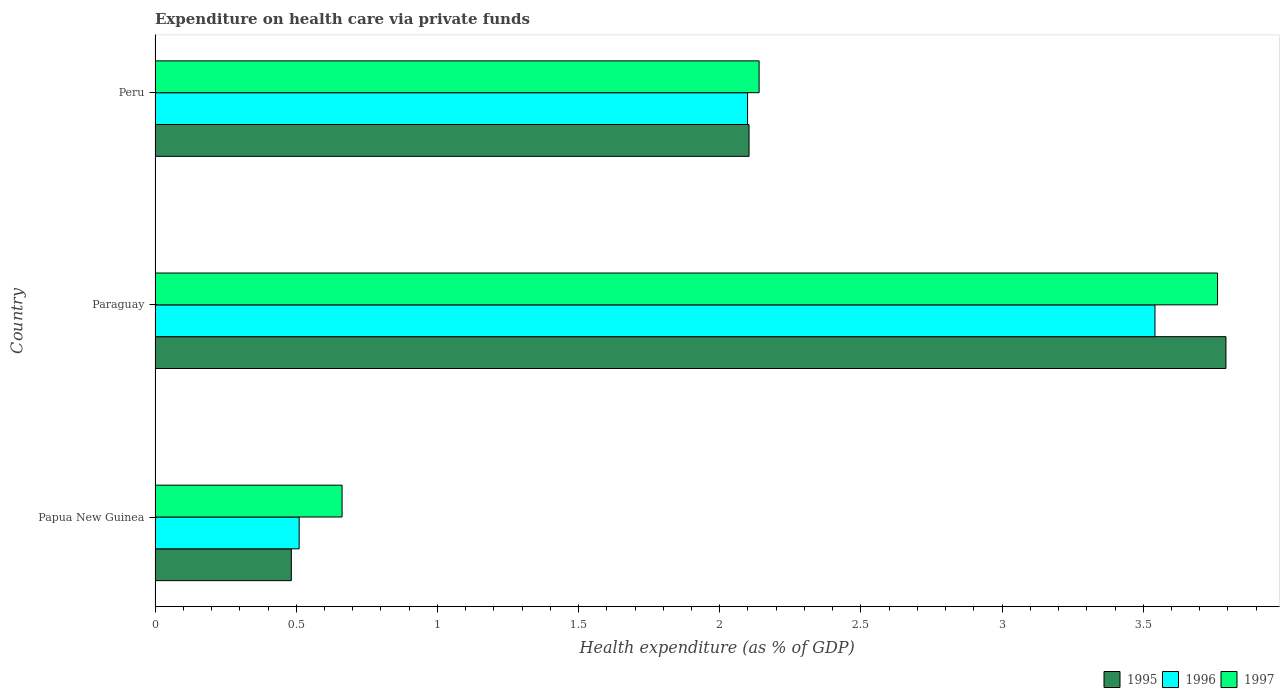How many different coloured bars are there?
Provide a short and direct response. 3. Are the number of bars per tick equal to the number of legend labels?
Your answer should be very brief. Yes. Are the number of bars on each tick of the Y-axis equal?
Give a very brief answer. Yes. What is the label of the 3rd group of bars from the top?
Ensure brevity in your answer.  Papua New Guinea. In how many cases, is the number of bars for a given country not equal to the number of legend labels?
Offer a very short reply. 0. What is the expenditure made on health care in 1997 in Peru?
Keep it short and to the point. 2.14. Across all countries, what is the maximum expenditure made on health care in 1997?
Provide a succinct answer. 3.76. Across all countries, what is the minimum expenditure made on health care in 1997?
Your answer should be very brief. 0.66. In which country was the expenditure made on health care in 1997 maximum?
Provide a succinct answer. Paraguay. In which country was the expenditure made on health care in 1995 minimum?
Ensure brevity in your answer.  Papua New Guinea. What is the total expenditure made on health care in 1996 in the graph?
Provide a short and direct response. 6.15. What is the difference between the expenditure made on health care in 1996 in Papua New Guinea and that in Peru?
Keep it short and to the point. -1.59. What is the difference between the expenditure made on health care in 1997 in Papua New Guinea and the expenditure made on health care in 1996 in Paraguay?
Provide a short and direct response. -2.88. What is the average expenditure made on health care in 1996 per country?
Keep it short and to the point. 2.05. What is the difference between the expenditure made on health care in 1997 and expenditure made on health care in 1996 in Peru?
Your response must be concise. 0.04. What is the ratio of the expenditure made on health care in 1997 in Papua New Guinea to that in Paraguay?
Make the answer very short. 0.18. What is the difference between the highest and the second highest expenditure made on health care in 1995?
Ensure brevity in your answer.  1.69. What is the difference between the highest and the lowest expenditure made on health care in 1995?
Give a very brief answer. 3.31. What does the 2nd bar from the bottom in Papua New Guinea represents?
Ensure brevity in your answer.  1996. Is it the case that in every country, the sum of the expenditure made on health care in 1996 and expenditure made on health care in 1997 is greater than the expenditure made on health care in 1995?
Make the answer very short. Yes. How many bars are there?
Your answer should be compact. 9. What is the difference between two consecutive major ticks on the X-axis?
Offer a very short reply. 0.5. Does the graph contain grids?
Your answer should be compact. No. How many legend labels are there?
Your response must be concise. 3. What is the title of the graph?
Ensure brevity in your answer.  Expenditure on health care via private funds. What is the label or title of the X-axis?
Your answer should be compact. Health expenditure (as % of GDP). What is the label or title of the Y-axis?
Your answer should be very brief. Country. What is the Health expenditure (as % of GDP) in 1995 in Papua New Guinea?
Ensure brevity in your answer.  0.48. What is the Health expenditure (as % of GDP) of 1996 in Papua New Guinea?
Offer a terse response. 0.51. What is the Health expenditure (as % of GDP) in 1997 in Papua New Guinea?
Your response must be concise. 0.66. What is the Health expenditure (as % of GDP) of 1995 in Paraguay?
Offer a very short reply. 3.79. What is the Health expenditure (as % of GDP) of 1996 in Paraguay?
Give a very brief answer. 3.54. What is the Health expenditure (as % of GDP) in 1997 in Paraguay?
Offer a terse response. 3.76. What is the Health expenditure (as % of GDP) in 1995 in Peru?
Make the answer very short. 2.1. What is the Health expenditure (as % of GDP) of 1996 in Peru?
Make the answer very short. 2.1. What is the Health expenditure (as % of GDP) of 1997 in Peru?
Provide a short and direct response. 2.14. Across all countries, what is the maximum Health expenditure (as % of GDP) in 1995?
Offer a very short reply. 3.79. Across all countries, what is the maximum Health expenditure (as % of GDP) of 1996?
Your answer should be very brief. 3.54. Across all countries, what is the maximum Health expenditure (as % of GDP) of 1997?
Offer a terse response. 3.76. Across all countries, what is the minimum Health expenditure (as % of GDP) in 1995?
Offer a very short reply. 0.48. Across all countries, what is the minimum Health expenditure (as % of GDP) of 1996?
Your answer should be compact. 0.51. Across all countries, what is the minimum Health expenditure (as % of GDP) of 1997?
Provide a succinct answer. 0.66. What is the total Health expenditure (as % of GDP) in 1995 in the graph?
Provide a short and direct response. 6.38. What is the total Health expenditure (as % of GDP) of 1996 in the graph?
Your answer should be very brief. 6.15. What is the total Health expenditure (as % of GDP) in 1997 in the graph?
Make the answer very short. 6.57. What is the difference between the Health expenditure (as % of GDP) in 1995 in Papua New Guinea and that in Paraguay?
Give a very brief answer. -3.31. What is the difference between the Health expenditure (as % of GDP) of 1996 in Papua New Guinea and that in Paraguay?
Provide a succinct answer. -3.03. What is the difference between the Health expenditure (as % of GDP) of 1997 in Papua New Guinea and that in Paraguay?
Your answer should be very brief. -3.1. What is the difference between the Health expenditure (as % of GDP) of 1995 in Papua New Guinea and that in Peru?
Offer a terse response. -1.62. What is the difference between the Health expenditure (as % of GDP) in 1996 in Papua New Guinea and that in Peru?
Your answer should be compact. -1.59. What is the difference between the Health expenditure (as % of GDP) in 1997 in Papua New Guinea and that in Peru?
Make the answer very short. -1.48. What is the difference between the Health expenditure (as % of GDP) in 1995 in Paraguay and that in Peru?
Offer a terse response. 1.69. What is the difference between the Health expenditure (as % of GDP) of 1996 in Paraguay and that in Peru?
Make the answer very short. 1.44. What is the difference between the Health expenditure (as % of GDP) of 1997 in Paraguay and that in Peru?
Give a very brief answer. 1.62. What is the difference between the Health expenditure (as % of GDP) in 1995 in Papua New Guinea and the Health expenditure (as % of GDP) in 1996 in Paraguay?
Offer a terse response. -3.06. What is the difference between the Health expenditure (as % of GDP) in 1995 in Papua New Guinea and the Health expenditure (as % of GDP) in 1997 in Paraguay?
Provide a short and direct response. -3.28. What is the difference between the Health expenditure (as % of GDP) of 1996 in Papua New Guinea and the Health expenditure (as % of GDP) of 1997 in Paraguay?
Your answer should be very brief. -3.25. What is the difference between the Health expenditure (as % of GDP) in 1995 in Papua New Guinea and the Health expenditure (as % of GDP) in 1996 in Peru?
Offer a terse response. -1.62. What is the difference between the Health expenditure (as % of GDP) in 1995 in Papua New Guinea and the Health expenditure (as % of GDP) in 1997 in Peru?
Provide a succinct answer. -1.66. What is the difference between the Health expenditure (as % of GDP) of 1996 in Papua New Guinea and the Health expenditure (as % of GDP) of 1997 in Peru?
Your response must be concise. -1.63. What is the difference between the Health expenditure (as % of GDP) in 1995 in Paraguay and the Health expenditure (as % of GDP) in 1996 in Peru?
Ensure brevity in your answer.  1.69. What is the difference between the Health expenditure (as % of GDP) in 1995 in Paraguay and the Health expenditure (as % of GDP) in 1997 in Peru?
Your answer should be compact. 1.65. What is the difference between the Health expenditure (as % of GDP) of 1996 in Paraguay and the Health expenditure (as % of GDP) of 1997 in Peru?
Make the answer very short. 1.4. What is the average Health expenditure (as % of GDP) of 1995 per country?
Provide a short and direct response. 2.13. What is the average Health expenditure (as % of GDP) of 1996 per country?
Your response must be concise. 2.05. What is the average Health expenditure (as % of GDP) in 1997 per country?
Provide a succinct answer. 2.19. What is the difference between the Health expenditure (as % of GDP) of 1995 and Health expenditure (as % of GDP) of 1996 in Papua New Guinea?
Your answer should be very brief. -0.03. What is the difference between the Health expenditure (as % of GDP) in 1995 and Health expenditure (as % of GDP) in 1997 in Papua New Guinea?
Your answer should be very brief. -0.18. What is the difference between the Health expenditure (as % of GDP) in 1996 and Health expenditure (as % of GDP) in 1997 in Papua New Guinea?
Your answer should be compact. -0.15. What is the difference between the Health expenditure (as % of GDP) in 1995 and Health expenditure (as % of GDP) in 1996 in Paraguay?
Your response must be concise. 0.25. What is the difference between the Health expenditure (as % of GDP) in 1995 and Health expenditure (as % of GDP) in 1997 in Paraguay?
Give a very brief answer. 0.03. What is the difference between the Health expenditure (as % of GDP) in 1996 and Health expenditure (as % of GDP) in 1997 in Paraguay?
Ensure brevity in your answer.  -0.22. What is the difference between the Health expenditure (as % of GDP) of 1995 and Health expenditure (as % of GDP) of 1996 in Peru?
Offer a very short reply. 0.01. What is the difference between the Health expenditure (as % of GDP) in 1995 and Health expenditure (as % of GDP) in 1997 in Peru?
Your answer should be compact. -0.04. What is the difference between the Health expenditure (as % of GDP) of 1996 and Health expenditure (as % of GDP) of 1997 in Peru?
Your response must be concise. -0.04. What is the ratio of the Health expenditure (as % of GDP) in 1995 in Papua New Guinea to that in Paraguay?
Provide a succinct answer. 0.13. What is the ratio of the Health expenditure (as % of GDP) of 1996 in Papua New Guinea to that in Paraguay?
Provide a succinct answer. 0.14. What is the ratio of the Health expenditure (as % of GDP) of 1997 in Papua New Guinea to that in Paraguay?
Keep it short and to the point. 0.18. What is the ratio of the Health expenditure (as % of GDP) in 1995 in Papua New Guinea to that in Peru?
Your response must be concise. 0.23. What is the ratio of the Health expenditure (as % of GDP) in 1996 in Papua New Guinea to that in Peru?
Keep it short and to the point. 0.24. What is the ratio of the Health expenditure (as % of GDP) of 1997 in Papua New Guinea to that in Peru?
Make the answer very short. 0.31. What is the ratio of the Health expenditure (as % of GDP) in 1995 in Paraguay to that in Peru?
Give a very brief answer. 1.8. What is the ratio of the Health expenditure (as % of GDP) of 1996 in Paraguay to that in Peru?
Offer a terse response. 1.69. What is the ratio of the Health expenditure (as % of GDP) in 1997 in Paraguay to that in Peru?
Give a very brief answer. 1.76. What is the difference between the highest and the second highest Health expenditure (as % of GDP) in 1995?
Keep it short and to the point. 1.69. What is the difference between the highest and the second highest Health expenditure (as % of GDP) in 1996?
Give a very brief answer. 1.44. What is the difference between the highest and the second highest Health expenditure (as % of GDP) in 1997?
Provide a succinct answer. 1.62. What is the difference between the highest and the lowest Health expenditure (as % of GDP) of 1995?
Give a very brief answer. 3.31. What is the difference between the highest and the lowest Health expenditure (as % of GDP) in 1996?
Give a very brief answer. 3.03. What is the difference between the highest and the lowest Health expenditure (as % of GDP) in 1997?
Ensure brevity in your answer.  3.1. 